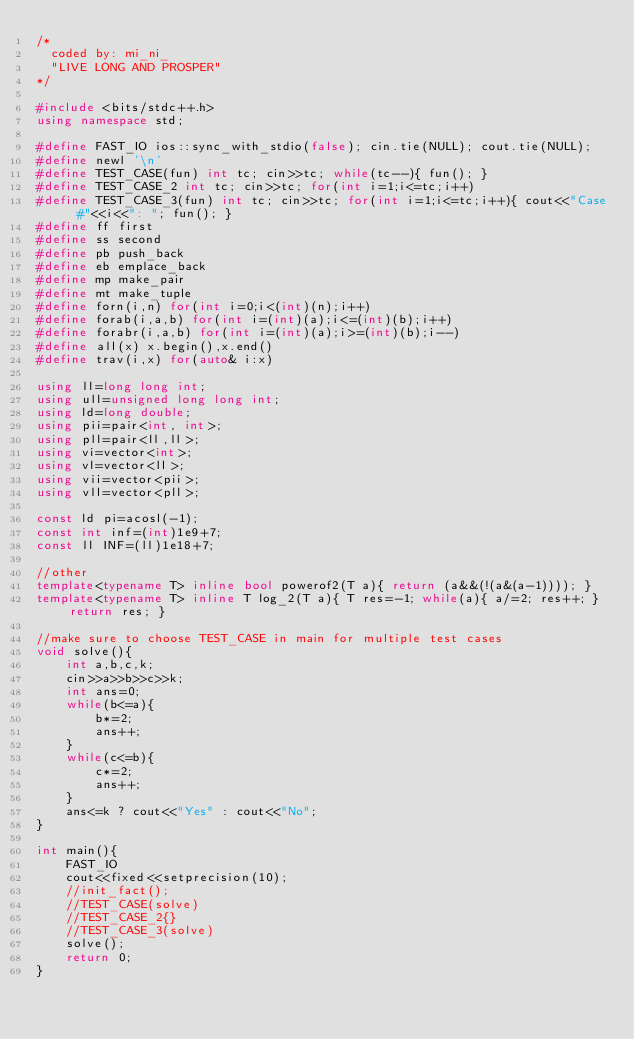Convert code to text. <code><loc_0><loc_0><loc_500><loc_500><_C++_>/*
  coded by: mi_ni_
  "LIVE LONG AND PROSPER"
*/
 
#include <bits/stdc++.h>
using namespace std;

#define FAST_IO ios::sync_with_stdio(false); cin.tie(NULL); cout.tie(NULL);
#define newl '\n'
#define TEST_CASE(fun) int tc; cin>>tc; while(tc--){ fun(); }
#define TEST_CASE_2 int tc; cin>>tc; for(int i=1;i<=tc;i++)
#define TEST_CASE_3(fun) int tc; cin>>tc; for(int i=1;i<=tc;i++){ cout<<"Case #"<<i<<": "; fun(); }
#define ff first
#define ss second
#define pb push_back
#define eb emplace_back
#define mp make_pair
#define mt make_tuple
#define forn(i,n) for(int i=0;i<(int)(n);i++)
#define forab(i,a,b) for(int i=(int)(a);i<=(int)(b);i++)
#define forabr(i,a,b) for(int i=(int)(a);i>=(int)(b);i--)
#define all(x) x.begin(),x.end()
#define trav(i,x) for(auto& i:x)

using ll=long long int;
using ull=unsigned long long int;
using ld=long double;
using pii=pair<int, int>;
using pll=pair<ll,ll>;
using vi=vector<int>;
using vl=vector<ll>;
using vii=vector<pii>;
using vll=vector<pll>;

const ld pi=acosl(-1);
const int inf=(int)1e9+7;
const ll INF=(ll)1e18+7;

//other
template<typename T> inline bool powerof2(T a){ return (a&&(!(a&(a-1)))); }
template<typename T> inline T log_2(T a){ T res=-1; while(a){ a/=2; res++; } return res; }

//make sure to choose TEST_CASE in main for multiple test cases
void solve(){
	int a,b,c,k;
	cin>>a>>b>>c>>k;
	int ans=0;
	while(b<=a){
		b*=2;
		ans++;
	}
	while(c<=b){
		c*=2;
		ans++;
	}
	ans<=k ? cout<<"Yes" : cout<<"No";
}

int main(){
    FAST_IO
    cout<<fixed<<setprecision(10);
    //init_fact();
    //TEST_CASE(solve)
    //TEST_CASE_2{}
    //TEST_CASE_3(solve)
    solve();
    return 0;
}</code> 